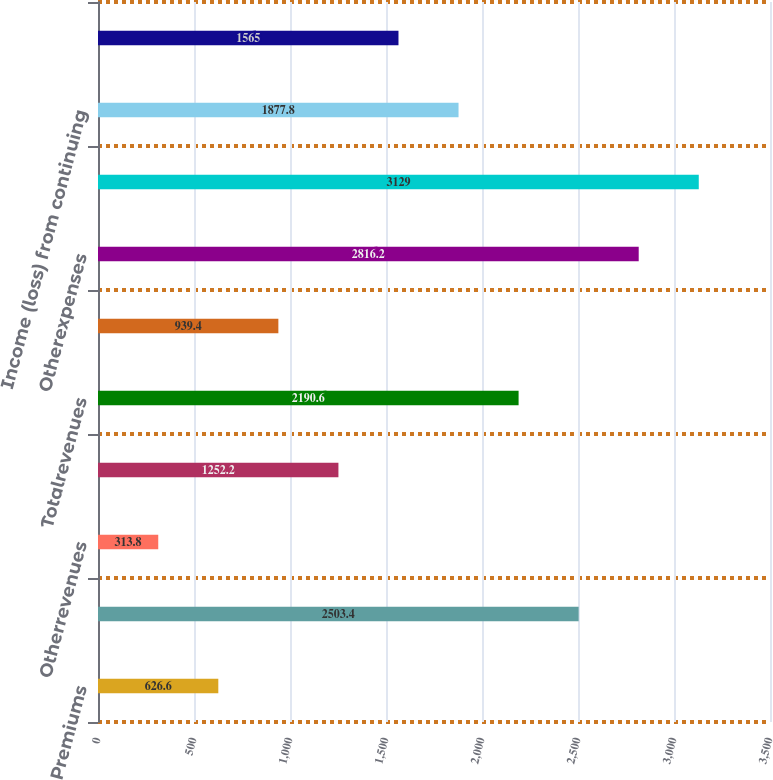Convert chart to OTSL. <chart><loc_0><loc_0><loc_500><loc_500><bar_chart><fcel>Premiums<fcel>Netinvestmentincome<fcel>Otherrevenues<fcel>Netinvestmentgains(losses)<fcel>Totalrevenues<fcel>Policyholderbenefitsandclaims<fcel>Otherexpenses<fcel>Totalexpenses<fcel>Income (loss) from continuing<fcel>Incometaxbenefit<nl><fcel>626.6<fcel>2503.4<fcel>313.8<fcel>1252.2<fcel>2190.6<fcel>939.4<fcel>2816.2<fcel>3129<fcel>1877.8<fcel>1565<nl></chart> 